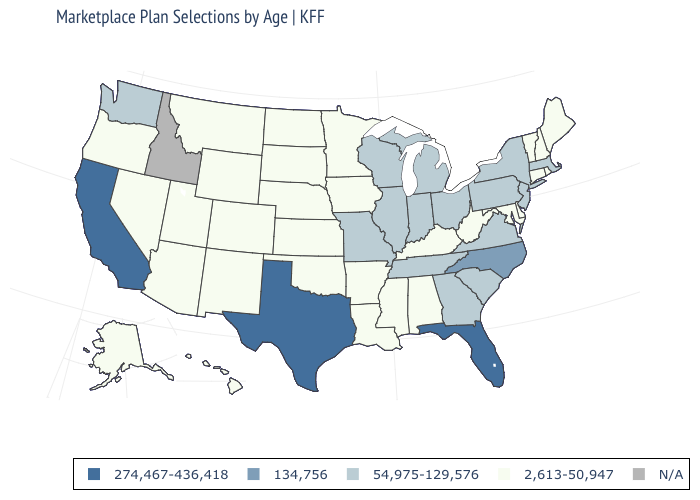What is the value of Wyoming?
Answer briefly. 2,613-50,947. Among the states that border New Jersey , does Pennsylvania have the highest value?
Be succinct. Yes. What is the lowest value in states that border Indiana?
Be succinct. 2,613-50,947. Name the states that have a value in the range 2,613-50,947?
Concise answer only. Alabama, Alaska, Arizona, Arkansas, Colorado, Connecticut, Delaware, Hawaii, Iowa, Kansas, Kentucky, Louisiana, Maine, Maryland, Minnesota, Mississippi, Montana, Nebraska, Nevada, New Hampshire, New Mexico, North Dakota, Oklahoma, Oregon, Rhode Island, South Dakota, Utah, Vermont, West Virginia, Wyoming. What is the value of Georgia?
Keep it brief. 54,975-129,576. What is the highest value in the South ?
Write a very short answer. 274,467-436,418. Does California have the highest value in the USA?
Answer briefly. Yes. Which states have the lowest value in the USA?
Short answer required. Alabama, Alaska, Arizona, Arkansas, Colorado, Connecticut, Delaware, Hawaii, Iowa, Kansas, Kentucky, Louisiana, Maine, Maryland, Minnesota, Mississippi, Montana, Nebraska, Nevada, New Hampshire, New Mexico, North Dakota, Oklahoma, Oregon, Rhode Island, South Dakota, Utah, Vermont, West Virginia, Wyoming. What is the highest value in the South ?
Answer briefly. 274,467-436,418. What is the value of California?
Answer briefly. 274,467-436,418. What is the highest value in the USA?
Answer briefly. 274,467-436,418. Does Mississippi have the lowest value in the USA?
Give a very brief answer. Yes. 